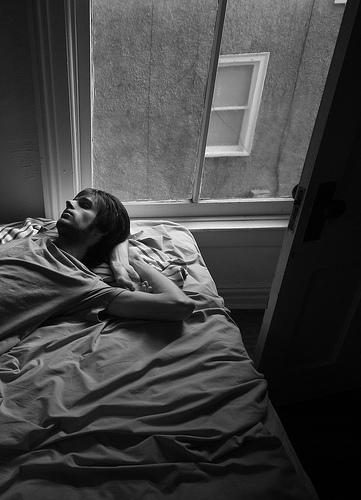Question: what is out the window?
Choices:
A. Another building.
B. A tree.
C. A mountain.
D. A shrub.
Answer with the letter. Answer: A Question: how is the person positioned?
Choices:
A. Lying down.
B. Standing up.
C. Upside down.
D. Upright.
Answer with the letter. Answer: A Question: why is the person lying down?
Choices:
A. He is resting.
B. He is asleep.
C. He is hurt.
D. He is working.
Answer with the letter. Answer: A Question: what is behind the person?
Choices:
A. A tree.
B. A chair.
C. A table.
D. A window.
Answer with the letter. Answer: D Question: who is in the picture?
Choices:
A. The woman.
B. The boy.
C. The man.
D. The girl.
Answer with the letter. Answer: C 